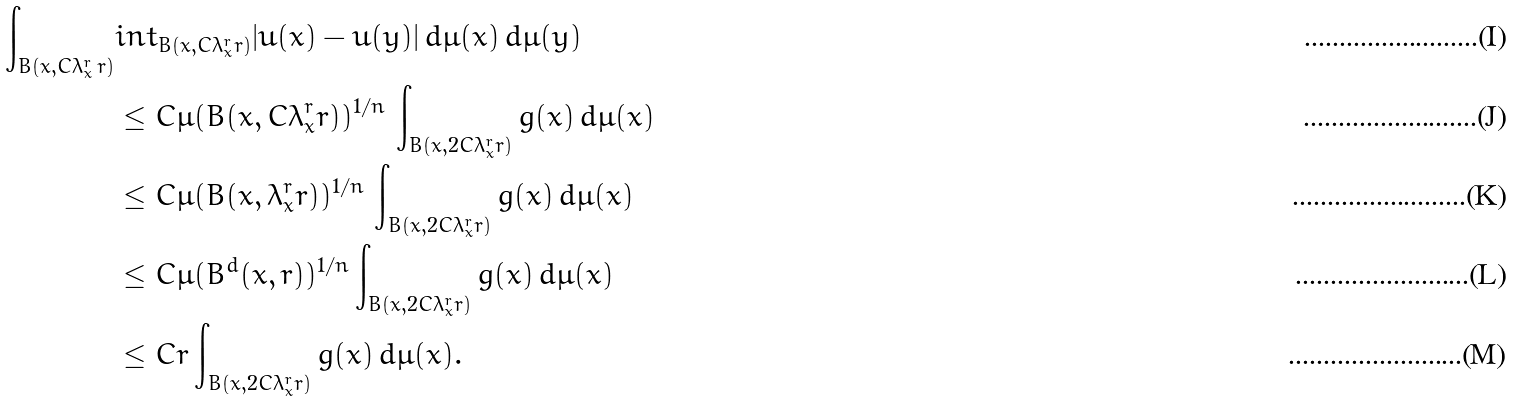Convert formula to latex. <formula><loc_0><loc_0><loc_500><loc_500>\int _ { B ( x , C \lambda _ { x } ^ { r } \, r ) } & \bar { i } n t _ { B ( x , C \lambda _ { x } ^ { r } r ) } | u ( x ) - u ( y ) | \, d \mu ( x ) \, d \mu ( y ) \\ & \leq C \mu ( B ( x , C \lambda _ { x } ^ { r } r ) ) ^ { 1 / n } \, \int _ { B ( x , 2 C \lambda _ { x } ^ { r } r ) } g ( x ) \, d \mu ( x ) \\ & \leq C \mu ( B ( x , \lambda _ { x } ^ { r } r ) ) ^ { 1 / n } \, \int _ { B ( x , 2 C \lambda _ { x } ^ { r } r ) } g ( x ) \, d \mu ( x ) \\ & \leq C \mu ( B ^ { d } ( x , r ) ) ^ { 1 / n } \int _ { B ( x , 2 C \lambda _ { x } ^ { r } r ) } g ( x ) \, d \mu ( x ) \\ & \leq C r \int _ { B ( x , 2 C \lambda _ { x } ^ { r } r ) } g ( x ) \, d \mu ( x ) .</formula> 